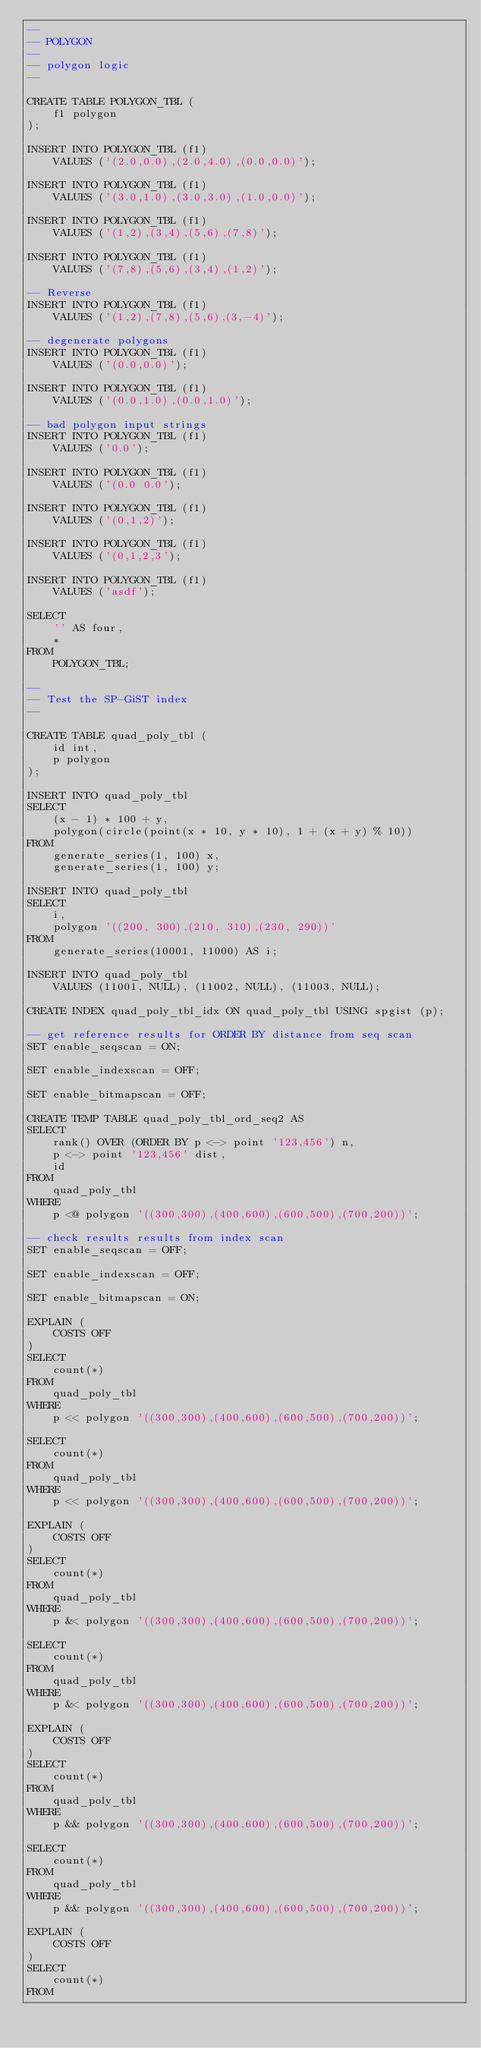<code> <loc_0><loc_0><loc_500><loc_500><_SQL_>--
-- POLYGON
--
-- polygon logic
--

CREATE TABLE POLYGON_TBL (
    f1 polygon
);

INSERT INTO POLYGON_TBL (f1)
    VALUES ('(2.0,0.0),(2.0,4.0),(0.0,0.0)');

INSERT INTO POLYGON_TBL (f1)
    VALUES ('(3.0,1.0),(3.0,3.0),(1.0,0.0)');

INSERT INTO POLYGON_TBL (f1)
    VALUES ('(1,2),(3,4),(5,6),(7,8)');

INSERT INTO POLYGON_TBL (f1)
    VALUES ('(7,8),(5,6),(3,4),(1,2)');

-- Reverse
INSERT INTO POLYGON_TBL (f1)
    VALUES ('(1,2),(7,8),(5,6),(3,-4)');

-- degenerate polygons
INSERT INTO POLYGON_TBL (f1)
    VALUES ('(0.0,0.0)');

INSERT INTO POLYGON_TBL (f1)
    VALUES ('(0.0,1.0),(0.0,1.0)');

-- bad polygon input strings
INSERT INTO POLYGON_TBL (f1)
    VALUES ('0.0');

INSERT INTO POLYGON_TBL (f1)
    VALUES ('(0.0 0.0');

INSERT INTO POLYGON_TBL (f1)
    VALUES ('(0,1,2)');

INSERT INTO POLYGON_TBL (f1)
    VALUES ('(0,1,2,3');

INSERT INTO POLYGON_TBL (f1)
    VALUES ('asdf');

SELECT
    '' AS four,
    *
FROM
    POLYGON_TBL;

--
-- Test the SP-GiST index
--

CREATE TABLE quad_poly_tbl (
    id int,
    p polygon
);

INSERT INTO quad_poly_tbl
SELECT
    (x - 1) * 100 + y,
    polygon(circle(point(x * 10, y * 10), 1 + (x + y) % 10))
FROM
    generate_series(1, 100) x,
    generate_series(1, 100) y;

INSERT INTO quad_poly_tbl
SELECT
    i,
    polygon '((200, 300),(210, 310),(230, 290))'
FROM
    generate_series(10001, 11000) AS i;

INSERT INTO quad_poly_tbl
    VALUES (11001, NULL), (11002, NULL), (11003, NULL);

CREATE INDEX quad_poly_tbl_idx ON quad_poly_tbl USING spgist (p);

-- get reference results for ORDER BY distance from seq scan
SET enable_seqscan = ON;

SET enable_indexscan = OFF;

SET enable_bitmapscan = OFF;

CREATE TEMP TABLE quad_poly_tbl_ord_seq2 AS
SELECT
    rank() OVER (ORDER BY p <-> point '123,456') n,
    p <-> point '123,456' dist,
    id
FROM
    quad_poly_tbl
WHERE
    p <@ polygon '((300,300),(400,600),(600,500),(700,200))';

-- check results results from index scan
SET enable_seqscan = OFF;

SET enable_indexscan = OFF;

SET enable_bitmapscan = ON;

EXPLAIN (
    COSTS OFF
)
SELECT
    count(*)
FROM
    quad_poly_tbl
WHERE
    p << polygon '((300,300),(400,600),(600,500),(700,200))';

SELECT
    count(*)
FROM
    quad_poly_tbl
WHERE
    p << polygon '((300,300),(400,600),(600,500),(700,200))';

EXPLAIN (
    COSTS OFF
)
SELECT
    count(*)
FROM
    quad_poly_tbl
WHERE
    p &< polygon '((300,300),(400,600),(600,500),(700,200))';

SELECT
    count(*)
FROM
    quad_poly_tbl
WHERE
    p &< polygon '((300,300),(400,600),(600,500),(700,200))';

EXPLAIN (
    COSTS OFF
)
SELECT
    count(*)
FROM
    quad_poly_tbl
WHERE
    p && polygon '((300,300),(400,600),(600,500),(700,200))';

SELECT
    count(*)
FROM
    quad_poly_tbl
WHERE
    p && polygon '((300,300),(400,600),(600,500),(700,200))';

EXPLAIN (
    COSTS OFF
)
SELECT
    count(*)
FROM</code> 